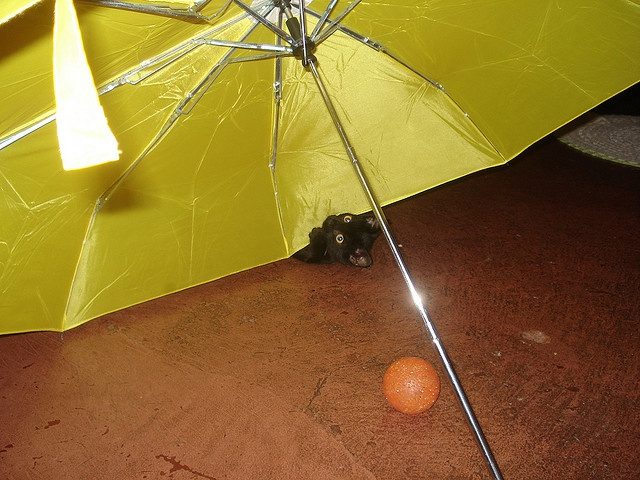Describe the objects in this image and their specific colors. I can see umbrella in khaki, olive, gold, and ivory tones, cat in khaki, black, maroon, olive, and gray tones, and sports ball in khaki, red, brown, and salmon tones in this image. 